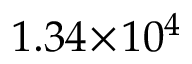<formula> <loc_0><loc_0><loc_500><loc_500>1 . 3 4 \, \times \, 1 0 ^ { 4 }</formula> 